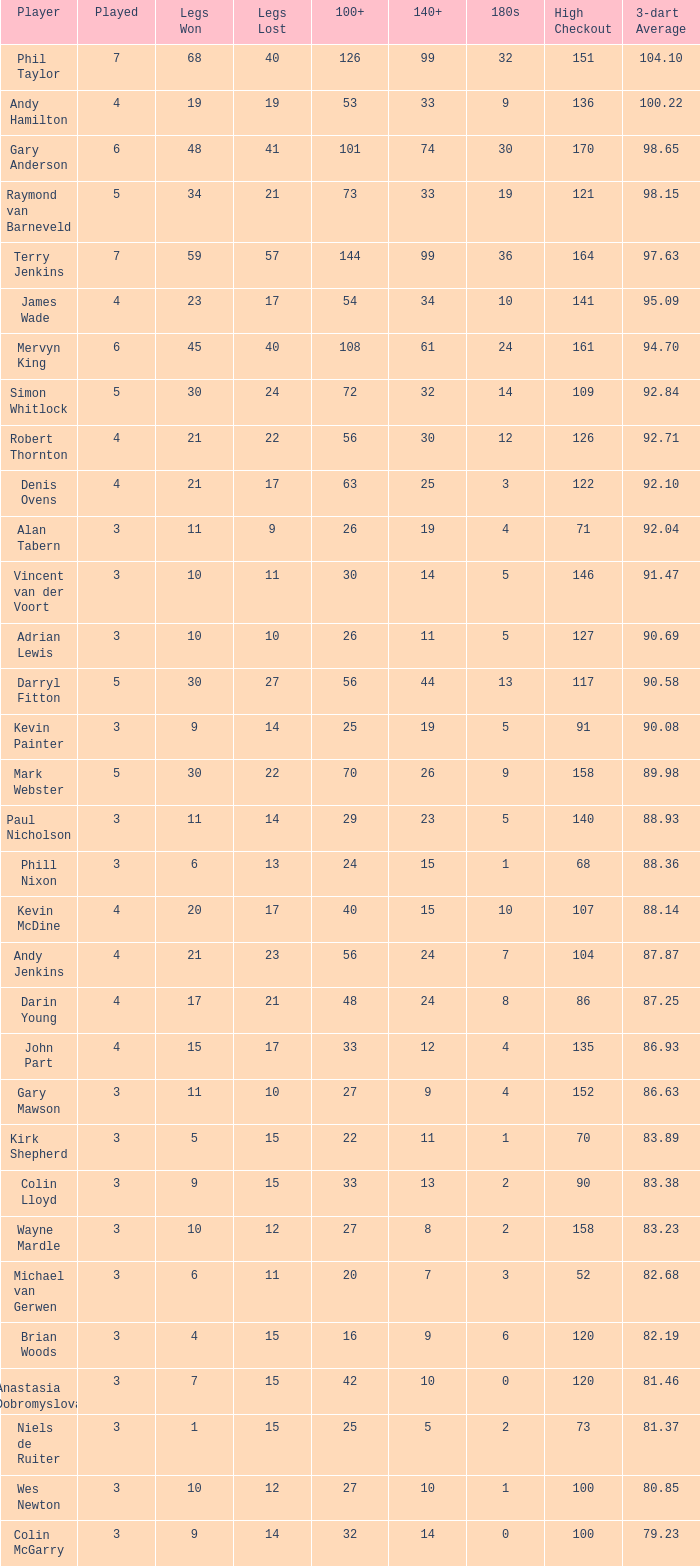With over 1 180s, a 100+ of 53, and less than 4 games played, what is the highest legs lost? None. 